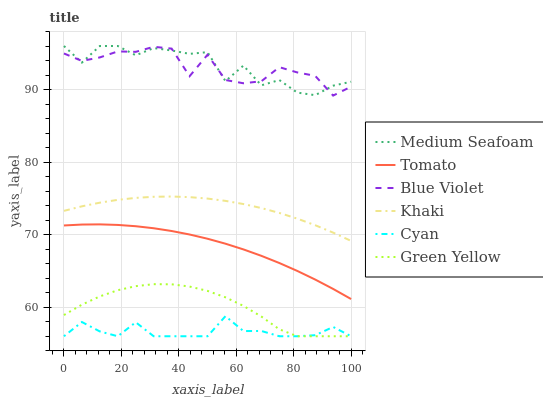Does Cyan have the minimum area under the curve?
Answer yes or no. Yes. Does Medium Seafoam have the maximum area under the curve?
Answer yes or no. Yes. Does Khaki have the minimum area under the curve?
Answer yes or no. No. Does Khaki have the maximum area under the curve?
Answer yes or no. No. Is Tomato the smoothest?
Answer yes or no. Yes. Is Medium Seafoam the roughest?
Answer yes or no. Yes. Is Khaki the smoothest?
Answer yes or no. No. Is Khaki the roughest?
Answer yes or no. No. Does Cyan have the lowest value?
Answer yes or no. Yes. Does Khaki have the lowest value?
Answer yes or no. No. Does Medium Seafoam have the highest value?
Answer yes or no. Yes. Does Khaki have the highest value?
Answer yes or no. No. Is Green Yellow less than Khaki?
Answer yes or no. Yes. Is Khaki greater than Cyan?
Answer yes or no. Yes. Does Medium Seafoam intersect Blue Violet?
Answer yes or no. Yes. Is Medium Seafoam less than Blue Violet?
Answer yes or no. No. Is Medium Seafoam greater than Blue Violet?
Answer yes or no. No. Does Green Yellow intersect Khaki?
Answer yes or no. No. 